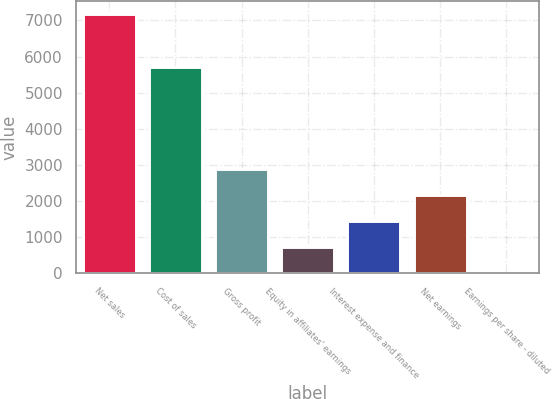<chart> <loc_0><loc_0><loc_500><loc_500><bar_chart><fcel>Net sales<fcel>Cost of sales<fcel>Gross profit<fcel>Equity in affiliates' earnings<fcel>Interest expense and finance<fcel>Net earnings<fcel>Earnings per share - diluted<nl><fcel>7183.2<fcel>5716.3<fcel>2875.77<fcel>722.07<fcel>1439.97<fcel>2157.87<fcel>4.17<nl></chart> 